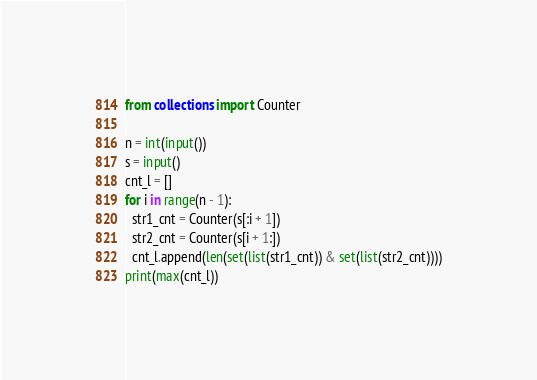<code> <loc_0><loc_0><loc_500><loc_500><_Python_>from collections import Counter

n = int(input())
s = input()
cnt_l = []
for i in range(n - 1):
  str1_cnt = Counter(s[:i + 1])
  str2_cnt = Counter(s[i + 1:])
  cnt_l.append(len(set(list(str1_cnt)) & set(list(str2_cnt))))
print(max(cnt_l))</code> 